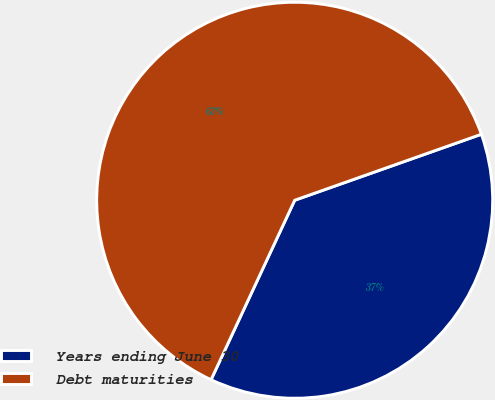Convert chart. <chart><loc_0><loc_0><loc_500><loc_500><pie_chart><fcel>Years ending June 30<fcel>Debt maturities<nl><fcel>37.35%<fcel>62.65%<nl></chart> 